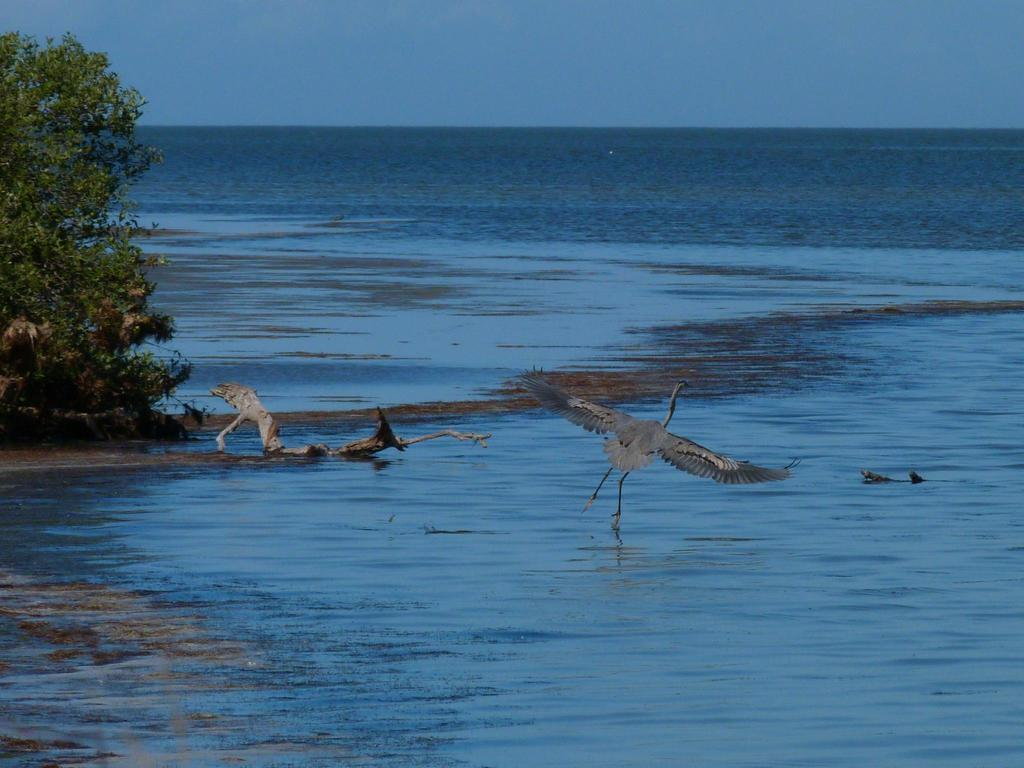What is the main subject of the image? The main subject of the image is a bird flying. What is located beneath the bird in the image? There is water visible beneath the bird in the image. What can be seen on the left side of the image? There is a tree on the left side of the image. What is visible at the top of the image? The sky is visible at the top of the image. How does the bird shake its wings while flying in the image? The image does not show the bird shaking its wings; it only shows the bird flying. Who is the creator of the bird in the image? The image does not provide information about the bird's creator. 